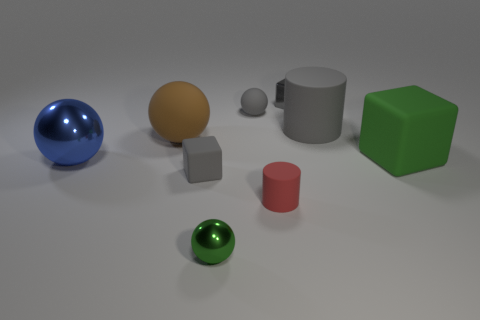There is a small green shiny object; is its shape the same as the tiny gray thing that is in front of the big gray rubber thing?
Give a very brief answer. No. The green matte object has what size?
Your answer should be compact. Large. Are there fewer small green balls that are behind the large gray object than small cylinders?
Your answer should be compact. Yes. How many cubes have the same size as the blue thing?
Provide a short and direct response. 1. What is the shape of the small thing that is the same color as the large rubber cube?
Provide a short and direct response. Sphere. There is a rubber cylinder that is right of the tiny gray metallic cube; is it the same color as the metal object on the right side of the tiny gray matte sphere?
Offer a terse response. Yes. There is a metal cube; how many big balls are behind it?
Your answer should be very brief. 0. There is a sphere that is the same color as the tiny metal cube; what is its size?
Your answer should be compact. Small. Are there any large brown matte things of the same shape as the large blue object?
Provide a short and direct response. Yes. What color is the rubber cylinder that is the same size as the brown rubber ball?
Your answer should be very brief. Gray. 